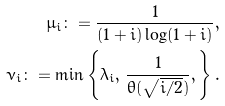Convert formula to latex. <formula><loc_0><loc_0><loc_500><loc_500>\mu _ { i } \colon = \frac { 1 } { ( 1 + i ) \log ( 1 + i ) } , \\ \nu _ { i } \colon = \min \left \{ \lambda _ { i } , \, \frac { 1 } { \theta ( \sqrt { i / 2 } ) } , \right \} .</formula> 